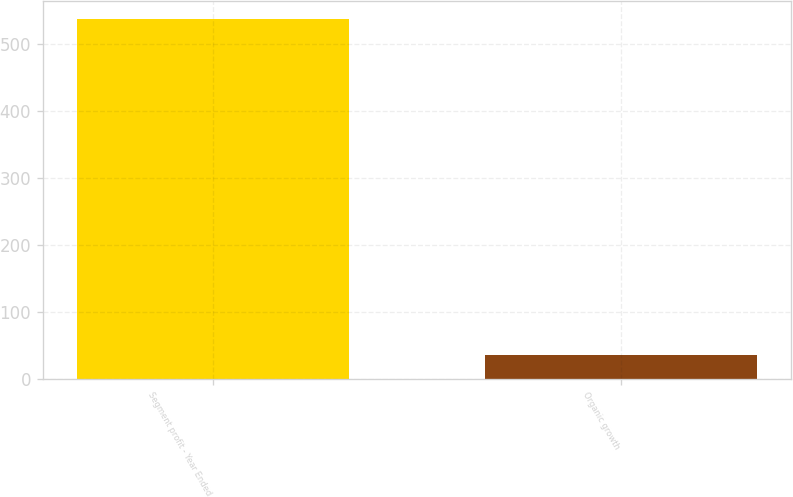Convert chart. <chart><loc_0><loc_0><loc_500><loc_500><bar_chart><fcel>Segment profit - Year Ended<fcel>Organic growth<nl><fcel>537.5<fcel>35<nl></chart> 